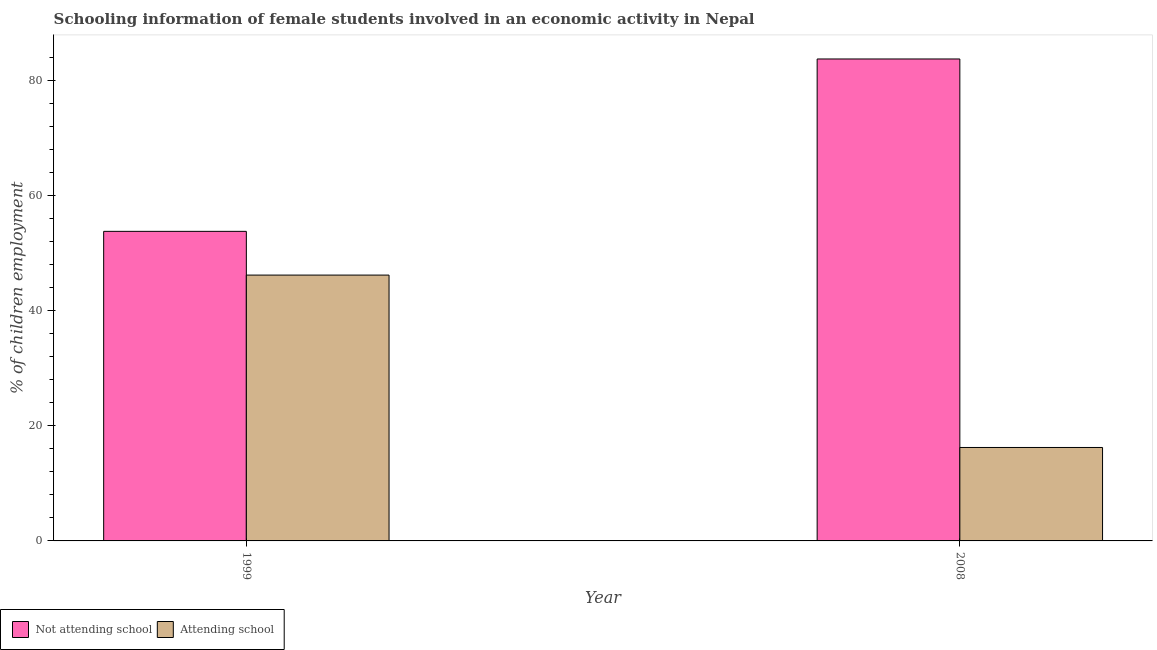Are the number of bars per tick equal to the number of legend labels?
Your answer should be very brief. Yes. How many bars are there on the 2nd tick from the left?
Offer a very short reply. 2. How many bars are there on the 1st tick from the right?
Make the answer very short. 2. What is the percentage of employed females who are attending school in 2008?
Offer a terse response. 16.24. Across all years, what is the maximum percentage of employed females who are not attending school?
Give a very brief answer. 83.76. Across all years, what is the minimum percentage of employed females who are attending school?
Make the answer very short. 16.24. In which year was the percentage of employed females who are attending school maximum?
Your answer should be very brief. 1999. In which year was the percentage of employed females who are not attending school minimum?
Ensure brevity in your answer.  1999. What is the total percentage of employed females who are attending school in the graph?
Provide a short and direct response. 62.44. What is the difference between the percentage of employed females who are not attending school in 1999 and that in 2008?
Provide a short and direct response. -29.96. What is the difference between the percentage of employed females who are not attending school in 2008 and the percentage of employed females who are attending school in 1999?
Offer a very short reply. 29.96. What is the average percentage of employed females who are not attending school per year?
Make the answer very short. 68.78. In how many years, is the percentage of employed females who are attending school greater than 8 %?
Make the answer very short. 2. What is the ratio of the percentage of employed females who are attending school in 1999 to that in 2008?
Offer a terse response. 2.84. Is the percentage of employed females who are not attending school in 1999 less than that in 2008?
Give a very brief answer. Yes. What does the 2nd bar from the left in 2008 represents?
Your response must be concise. Attending school. What does the 1st bar from the right in 1999 represents?
Your answer should be very brief. Attending school. Are all the bars in the graph horizontal?
Your answer should be very brief. No. What is the difference between two consecutive major ticks on the Y-axis?
Keep it short and to the point. 20. Are the values on the major ticks of Y-axis written in scientific E-notation?
Make the answer very short. No. Where does the legend appear in the graph?
Provide a short and direct response. Bottom left. How many legend labels are there?
Ensure brevity in your answer.  2. What is the title of the graph?
Provide a succinct answer. Schooling information of female students involved in an economic activity in Nepal. Does "Investment" appear as one of the legend labels in the graph?
Offer a terse response. No. What is the label or title of the Y-axis?
Your answer should be compact. % of children employment. What is the % of children employment of Not attending school in 1999?
Make the answer very short. 53.8. What is the % of children employment in Attending school in 1999?
Provide a succinct answer. 46.2. What is the % of children employment of Not attending school in 2008?
Your response must be concise. 83.76. What is the % of children employment of Attending school in 2008?
Ensure brevity in your answer.  16.24. Across all years, what is the maximum % of children employment of Not attending school?
Make the answer very short. 83.76. Across all years, what is the maximum % of children employment of Attending school?
Provide a succinct answer. 46.2. Across all years, what is the minimum % of children employment in Not attending school?
Offer a terse response. 53.8. Across all years, what is the minimum % of children employment in Attending school?
Offer a very short reply. 16.24. What is the total % of children employment in Not attending school in the graph?
Your response must be concise. 137.56. What is the total % of children employment in Attending school in the graph?
Offer a very short reply. 62.44. What is the difference between the % of children employment in Not attending school in 1999 and that in 2008?
Your response must be concise. -29.96. What is the difference between the % of children employment in Attending school in 1999 and that in 2008?
Ensure brevity in your answer.  29.96. What is the difference between the % of children employment in Not attending school in 1999 and the % of children employment in Attending school in 2008?
Keep it short and to the point. 37.56. What is the average % of children employment of Not attending school per year?
Your response must be concise. 68.78. What is the average % of children employment in Attending school per year?
Make the answer very short. 31.22. In the year 2008, what is the difference between the % of children employment in Not attending school and % of children employment in Attending school?
Make the answer very short. 67.52. What is the ratio of the % of children employment of Not attending school in 1999 to that in 2008?
Offer a terse response. 0.64. What is the ratio of the % of children employment of Attending school in 1999 to that in 2008?
Provide a short and direct response. 2.84. What is the difference between the highest and the second highest % of children employment of Not attending school?
Keep it short and to the point. 29.96. What is the difference between the highest and the second highest % of children employment in Attending school?
Make the answer very short. 29.96. What is the difference between the highest and the lowest % of children employment in Not attending school?
Ensure brevity in your answer.  29.96. What is the difference between the highest and the lowest % of children employment of Attending school?
Your answer should be compact. 29.96. 